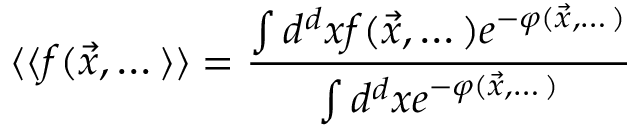<formula> <loc_0><loc_0><loc_500><loc_500>\langle \langle f ( { \vec { x } } , \dots \rangle \rangle = \frac { \int d ^ { d } x f ( { \vec { x } } , \dots ) e ^ { - \varphi ( { \vec { x } } , \dots ) } } { \int d ^ { d } x e ^ { - \varphi ( { \vec { x } } , \dots ) } }</formula> 